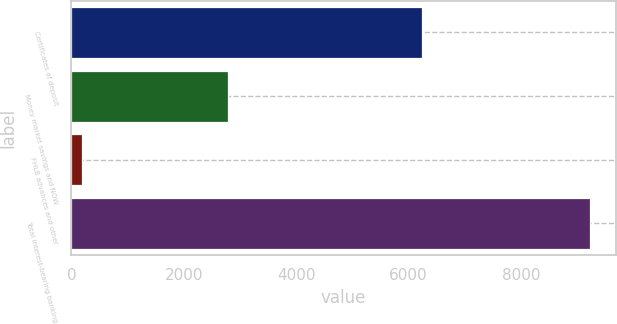Convert chart. <chart><loc_0><loc_0><loc_500><loc_500><bar_chart><fcel>Certificates of deposit<fcel>Money market savings and NOW<fcel>FHLB advances and other<fcel>Total interest-bearing banking<nl><fcel>6239<fcel>2793<fcel>192<fcel>9224<nl></chart> 